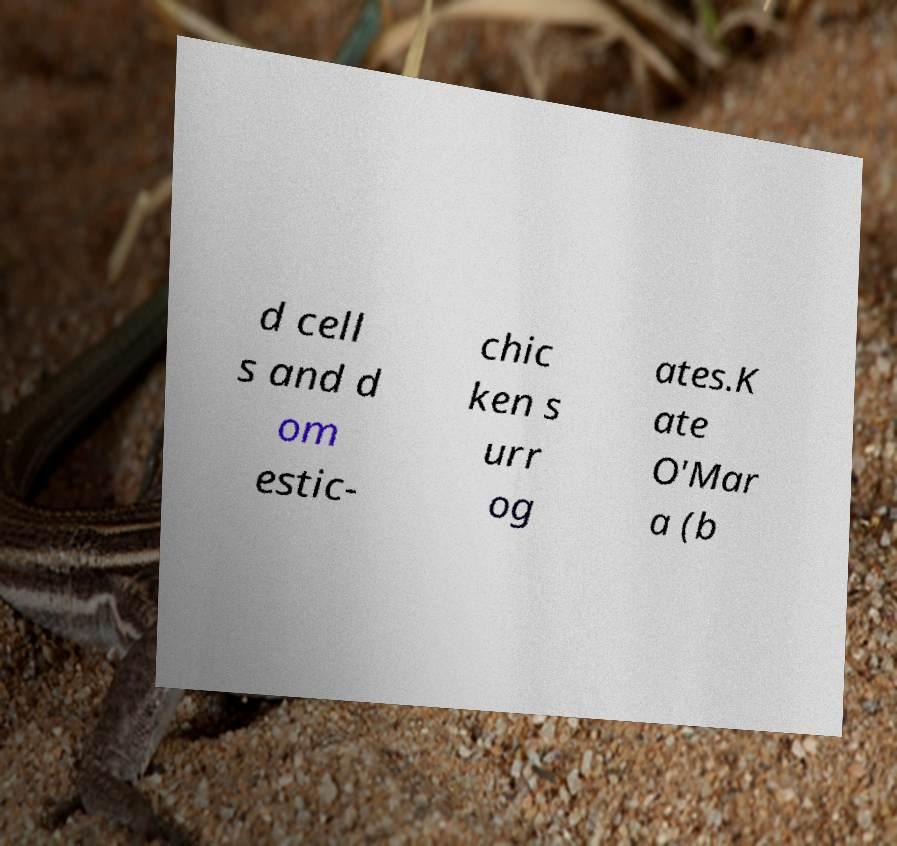There's text embedded in this image that I need extracted. Can you transcribe it verbatim? d cell s and d om estic- chic ken s urr og ates.K ate O'Mar a (b 